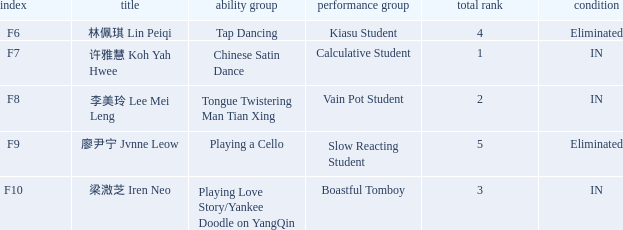For all events with index f10, what is the sum of the overall rankings? 3.0. 